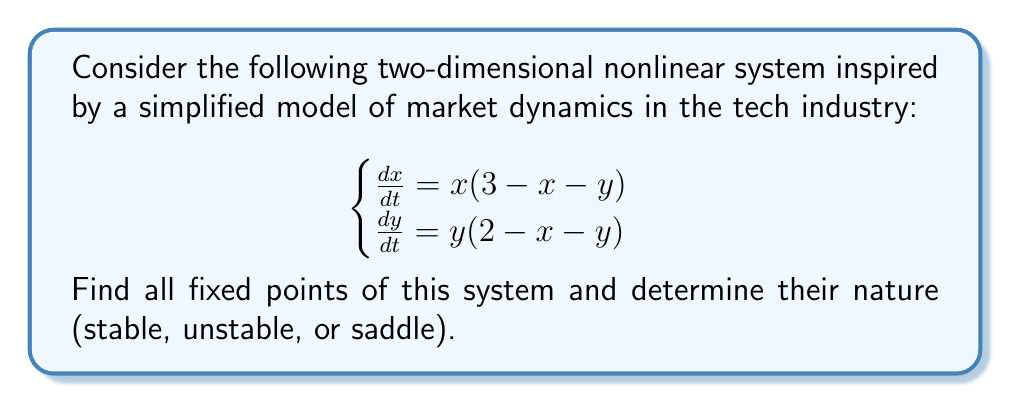Solve this math problem. 1. To find the fixed points, set both equations to zero:
   $$\begin{cases}
   x(3 - x - y) = 0 \\
   y(2 - x - y) = 0
   \end{cases}$$

2. Solve the system:
   a) $x = 0$ or $3 - x - y = 0$
   b) $y = 0$ or $2 - x - y = 0$

3. Combine these conditions to find fixed points:
   - $(0, 0)$
   - $(3, 0)$
   - $(0, 2)$
   - $(1, 2)$ (intersection of $3 - x - y = 0$ and $2 - x - y = 0$)

4. To determine the nature of each fixed point, calculate the Jacobian matrix:
   $$J = \begin{bmatrix}
   3 - 2x - y & -x \\
   -y & 2 - x - 2y
   \end{bmatrix}$$

5. Evaluate the Jacobian at each fixed point:

   a) At $(0, 0)$: $J_{(0,0)} = \begin{bmatrix} 3 & 0 \\ 0 & 2 \end{bmatrix}$
      Eigenvalues: $\lambda_1 = 3$, $\lambda_2 = 2$
      Both positive: unstable node

   b) At $(3, 0)$: $J_{(3,0)} = \begin{bmatrix} -3 & -3 \\ 0 & -1 \end{bmatrix}$
      Eigenvalues: $\lambda_1 = -3$, $\lambda_2 = -1$
      Both negative: stable node

   c) At $(0, 2)$: $J_{(0,2)} = \begin{bmatrix} 1 & 0 \\ -2 & -2 \end{bmatrix}$
      Eigenvalues: $\lambda_1 = 1$, $\lambda_2 = -2$
      One positive, one negative: saddle point

   d) At $(1, 2)$: $J_{(1,2)} = \begin{bmatrix} -1 & -1 \\ -2 & -1 \end{bmatrix}$
      Eigenvalues: $\lambda_{1,2} = -1 \pm i$
      Real parts negative: stable spiral
Answer: Fixed points: $(0,0)$ (unstable), $(3,0)$ (stable), $(0,2)$ (saddle), $(1,2)$ (stable spiral). 